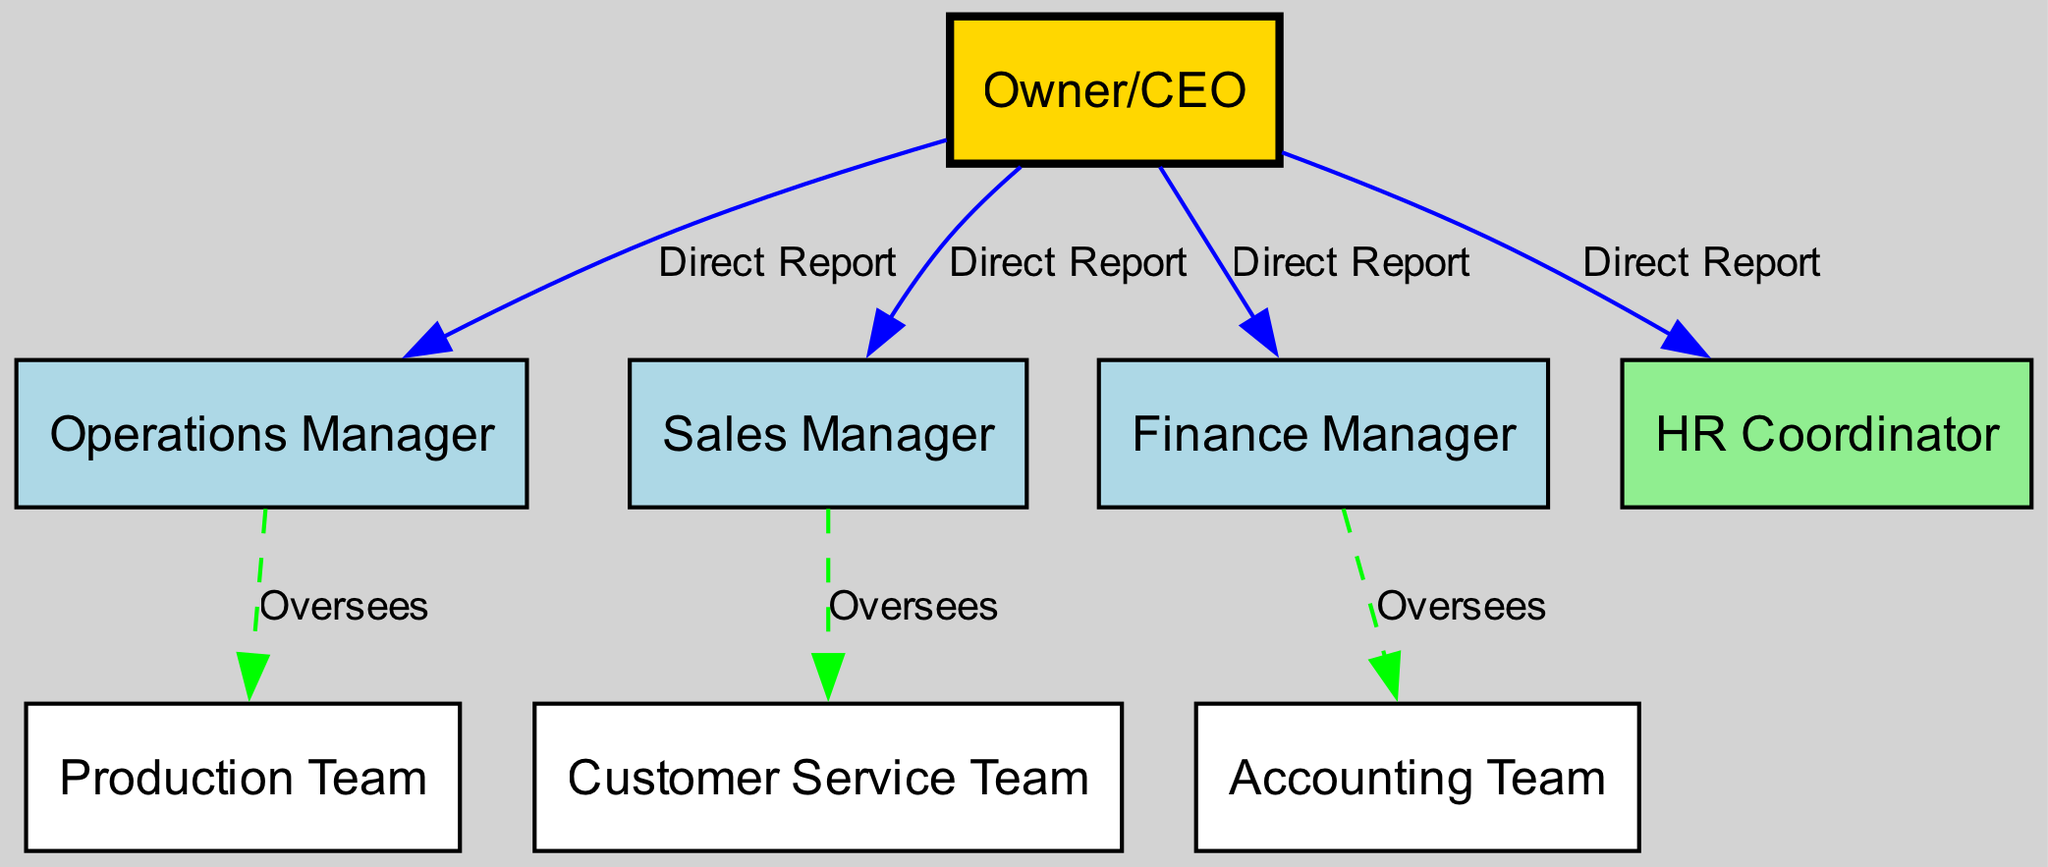What is the label of the top node in the diagram? The top node represents the highest authority in the organizational structure, which is labeled as "Owner/CEO."
Answer: Owner/CEO How many total nodes are in the diagram? To find the number of nodes, we count each distinct entity represented. There are eight nodes in total.
Answer: 8 What is the relationship between the Owner and the Finance Manager? In the diagram, the Owner has a direct reporting relationship with the Finance Manager, indicated by the label "Direct Report."
Answer: Direct Report Which department does the Operations Manager oversee? The Operations Manager oversees the Production Team, shown by the connecting edge labeled "Oversees."
Answer: Production Team How many direct reports does the Owner have? By examining the edges connecting to the Owner, we see there are four direct reports: Operations Manager, Sales Manager, Finance Manager, and HR Coordinator.
Answer: 4 What color represents the HR Coordinator in the diagram? The HR Coordinator's node is colored light green, distinct from the other roles in the organizational structure.
Answer: Light Green Which team does the Sales Manager oversee? According to the diagram, the Sales Manager oversees the Customer Service Team, as indicated by the label on the edge.
Answer: Customer Service Team What is the connection type between the Finance Manager and the Accounting Team? The Finance Manager has an overseeing relationship with the Accounting Team, which is shown with a dashed edge labeled "Oversees."
Answer: Oversees If the Owner reports to no one, who are the direct reports under the Owner? The Owner reports directly to the Operations Manager, Sales Manager, Finance Manager, and HR Coordinator; these four make up the Owner's direct reports.
Answer: Operations Manager, Sales Manager, Finance Manager, HR Coordinator How is the Operations Manager depicted in terms of color? The Operations Manager's node is depicted in light blue, indicating its categorization in the diagram among upper management roles.
Answer: Light Blue 